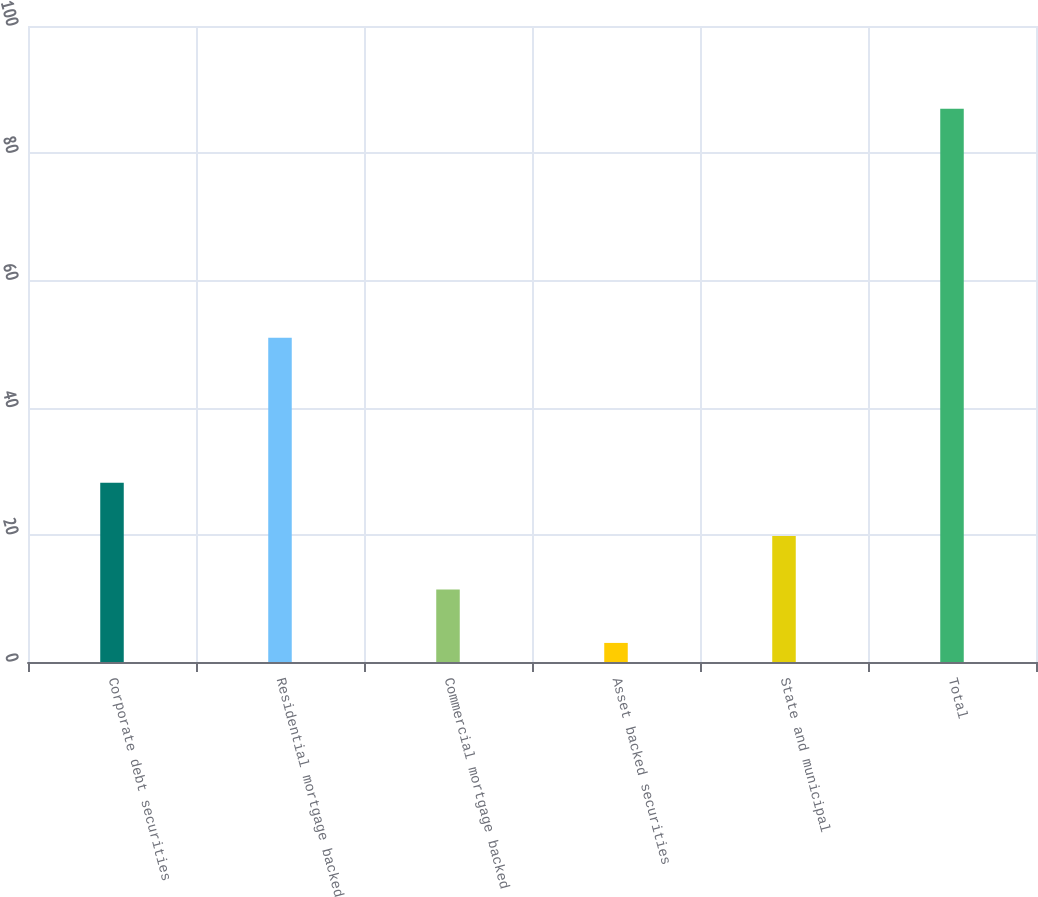Convert chart to OTSL. <chart><loc_0><loc_0><loc_500><loc_500><bar_chart><fcel>Corporate debt securities<fcel>Residential mortgage backed<fcel>Commercial mortgage backed<fcel>Asset backed securities<fcel>State and municipal<fcel>Total<nl><fcel>28.2<fcel>51<fcel>11.4<fcel>3<fcel>19.8<fcel>87<nl></chart> 